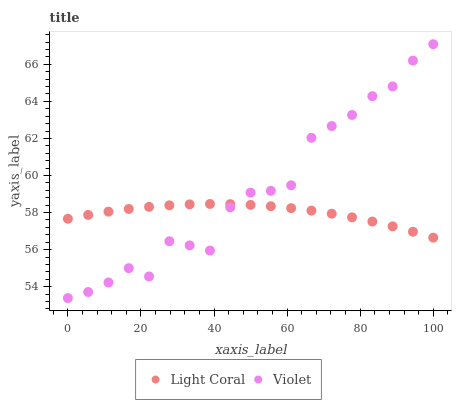Does Light Coral have the minimum area under the curve?
Answer yes or no. Yes. Does Violet have the maximum area under the curve?
Answer yes or no. Yes. Does Violet have the minimum area under the curve?
Answer yes or no. No. Is Light Coral the smoothest?
Answer yes or no. Yes. Is Violet the roughest?
Answer yes or no. Yes. Is Violet the smoothest?
Answer yes or no. No. Does Violet have the lowest value?
Answer yes or no. Yes. Does Violet have the highest value?
Answer yes or no. Yes. Does Violet intersect Light Coral?
Answer yes or no. Yes. Is Violet less than Light Coral?
Answer yes or no. No. Is Violet greater than Light Coral?
Answer yes or no. No. 